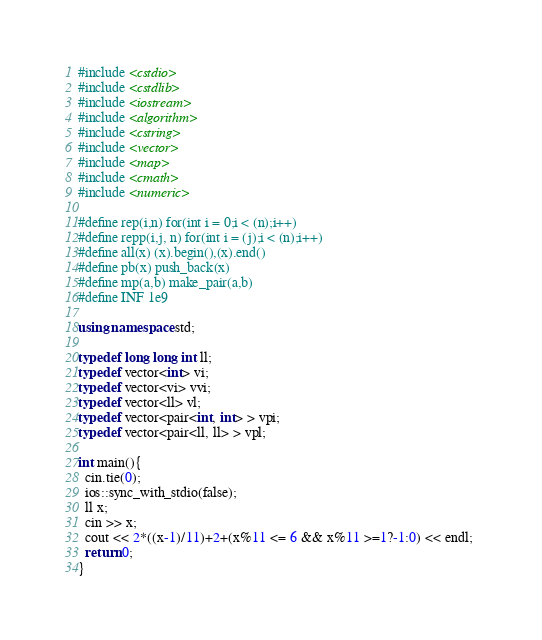<code> <loc_0><loc_0><loc_500><loc_500><_C++_>#include <cstdio>
#include <cstdlib>
#include <iostream>
#include <algorithm>
#include <cstring>
#include <vector>
#include <map>
#include <cmath>
#include <numeric>

#define rep(i,n) for(int i = 0;i < (n);i++)
#define repp(i,j, n) for(int i = (j);i < (n);i++)
#define all(x) (x).begin(),(x).end()
#define pb(x) push_back(x)
#define mp(a,b) make_pair(a,b)
#define INF 1e9

using namespace std;

typedef long long int ll;
typedef vector<int> vi;
typedef vector<vi> vvi;
typedef vector<ll> vl;
typedef vector<pair<int, int> > vpi;
typedef vector<pair<ll, ll> > vpl;

int main(){
  cin.tie(0);
  ios::sync_with_stdio(false);
  ll x;
  cin >> x;
  cout << 2*((x-1)/11)+2+(x%11 <= 6 && x%11 >=1?-1:0) << endl; 
  return 0;
}
</code> 